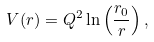Convert formula to latex. <formula><loc_0><loc_0><loc_500><loc_500>V ( r ) = Q ^ { 2 } \ln \left ( \frac { r _ { 0 } } { r } \right ) ,</formula> 